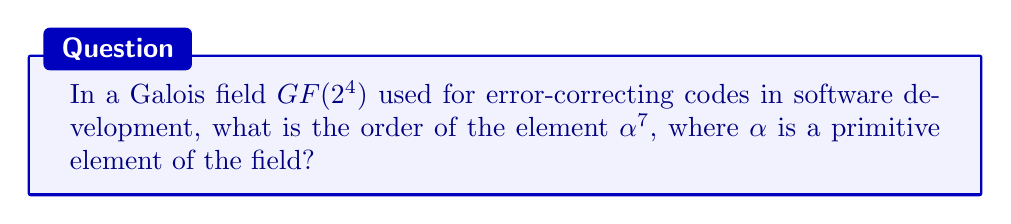Could you help me with this problem? To solve this problem, we'll follow these steps:

1. Understand the properties of $GF(2^4)$:
   - The field has $2^4 = 16$ elements
   - The multiplicative group has $16 - 1 = 15$ non-zero elements

2. Recall that $\alpha$ is a primitive element:
   - This means that $\alpha$ generates all non-zero elements
   - The order of $\alpha$ is 15

3. Use the property that for any element $\beta$ in a finite field:
   $\text{order}(\beta^k) = \frac{\text{order}(\beta)}{\gcd(k, \text{order}(\beta))}$

4. In our case:
   $\text{order}(\alpha^7) = \frac{\text{order}(\alpha)}{\gcd(7, \text{order}(\alpha))}$

5. Substitute the known values:
   $\text{order}(\alpha^7) = \frac{15}{\gcd(7, 15)}$

6. Calculate $\gcd(7, 15)$:
   $15 = 2 \times 7 + 1$
   $7 = 7 \times 1 + 0$
   Therefore, $\gcd(7, 15) = 1$

7. Finalize the calculation:
   $\text{order}(\alpha^7) = \frac{15}{1} = 15$

Thus, the order of $\alpha^7$ in $GF(2^4)$ is 15.
Answer: 15 